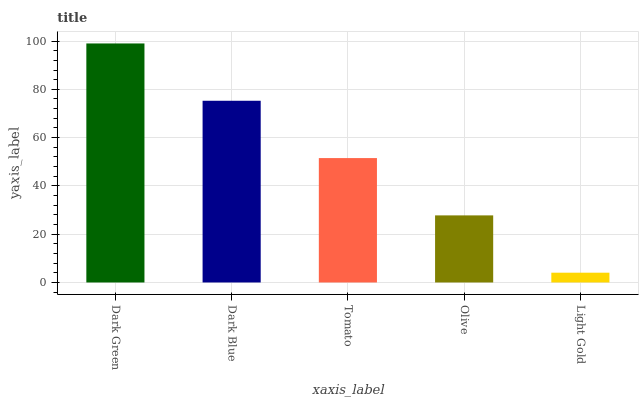Is Light Gold the minimum?
Answer yes or no. Yes. Is Dark Green the maximum?
Answer yes or no. Yes. Is Dark Blue the minimum?
Answer yes or no. No. Is Dark Blue the maximum?
Answer yes or no. No. Is Dark Green greater than Dark Blue?
Answer yes or no. Yes. Is Dark Blue less than Dark Green?
Answer yes or no. Yes. Is Dark Blue greater than Dark Green?
Answer yes or no. No. Is Dark Green less than Dark Blue?
Answer yes or no. No. Is Tomato the high median?
Answer yes or no. Yes. Is Tomato the low median?
Answer yes or no. Yes. Is Olive the high median?
Answer yes or no. No. Is Light Gold the low median?
Answer yes or no. No. 